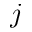<formula> <loc_0><loc_0><loc_500><loc_500>j</formula> 